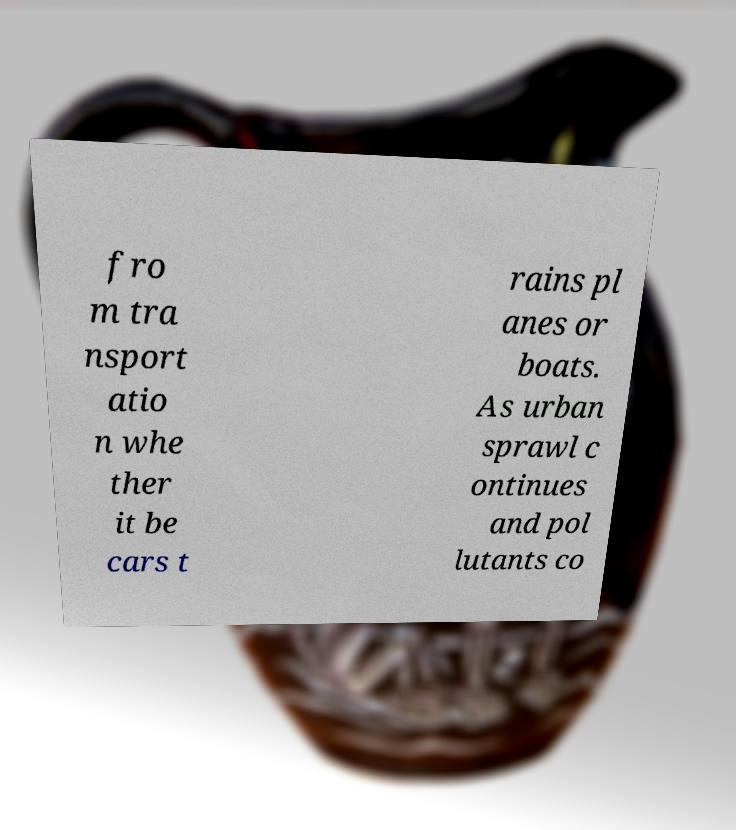I need the written content from this picture converted into text. Can you do that? fro m tra nsport atio n whe ther it be cars t rains pl anes or boats. As urban sprawl c ontinues and pol lutants co 